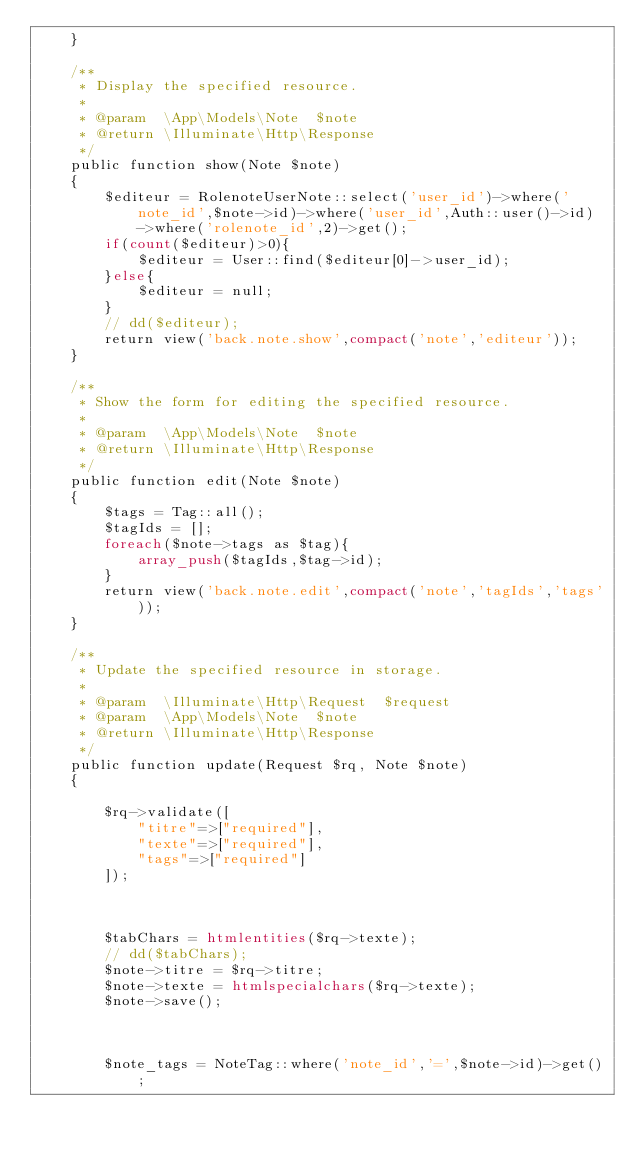<code> <loc_0><loc_0><loc_500><loc_500><_PHP_>    }

    /**
     * Display the specified resource.
     *
     * @param  \App\Models\Note  $note
     * @return \Illuminate\Http\Response
     */
    public function show(Note $note)
    {
        $editeur = RolenoteUserNote::select('user_id')->where('note_id',$note->id)->where('user_id',Auth::user()->id)->where('rolenote_id',2)->get();
        if(count($editeur)>0){
            $editeur = User::find($editeur[0]->user_id);
        }else{
            $editeur = null;
        }
        // dd($editeur);
        return view('back.note.show',compact('note','editeur'));
    }

    /**
     * Show the form for editing the specified resource.
     *
     * @param  \App\Models\Note  $note
     * @return \Illuminate\Http\Response
     */
    public function edit(Note $note)
    {
        $tags = Tag::all();
        $tagIds = [];
        foreach($note->tags as $tag){
            array_push($tagIds,$tag->id);
        }
        return view('back.note.edit',compact('note','tagIds','tags'));
    }

    /**
     * Update the specified resource in storage.
     *
     * @param  \Illuminate\Http\Request  $request
     * @param  \App\Models\Note  $note
     * @return \Illuminate\Http\Response
     */
    public function update(Request $rq, Note $note)
    {
        
        $rq->validate([
            "titre"=>["required"],
            "texte"=>["required"],
            "tags"=>["required"]
        ]);



        $tabChars = htmlentities($rq->texte);
        // dd($tabChars);
        $note->titre = $rq->titre;
        $note->texte = htmlspecialchars($rq->texte);
        $note->save();



        $note_tags = NoteTag::where('note_id','=',$note->id)->get();</code> 